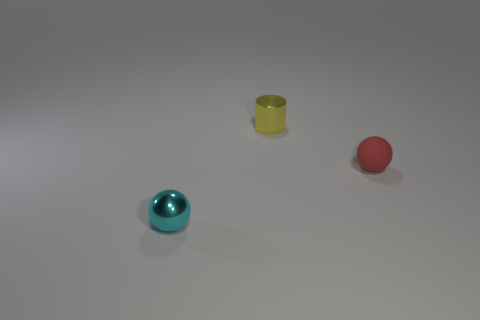Add 2 cyan cubes. How many objects exist? 5 Subtract all spheres. How many objects are left? 1 Add 1 small yellow metal cylinders. How many small yellow metal cylinders are left? 2 Add 1 blue cylinders. How many blue cylinders exist? 1 Subtract 1 yellow cylinders. How many objects are left? 2 Subtract all small gray shiny cubes. Subtract all small spheres. How many objects are left? 1 